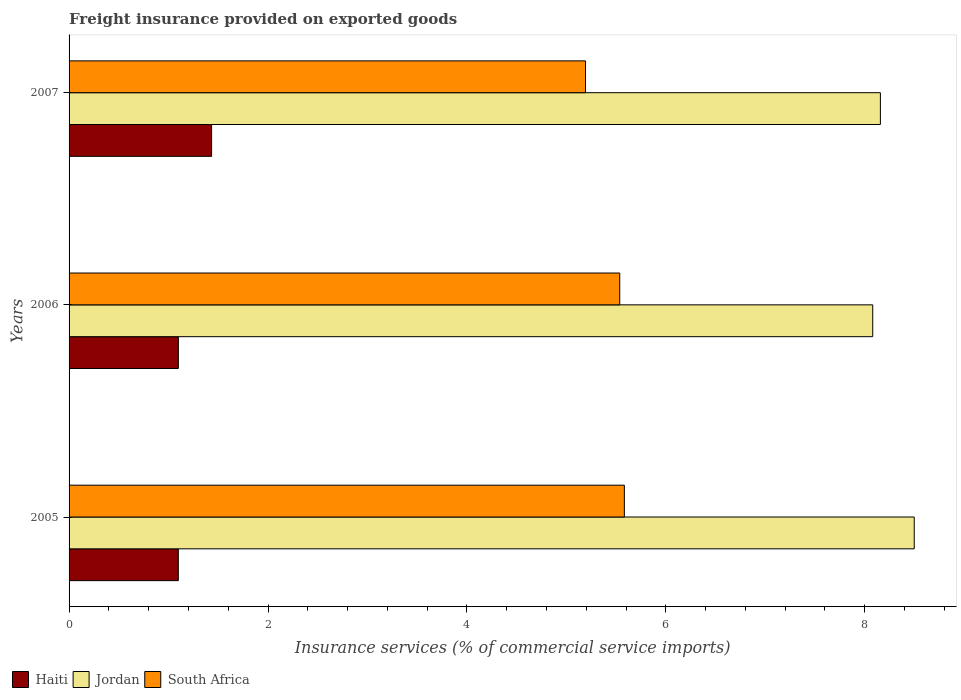How many groups of bars are there?
Offer a terse response. 3. Are the number of bars on each tick of the Y-axis equal?
Ensure brevity in your answer.  Yes. How many bars are there on the 2nd tick from the top?
Ensure brevity in your answer.  3. What is the freight insurance provided on exported goods in Haiti in 2005?
Give a very brief answer. 1.1. Across all years, what is the maximum freight insurance provided on exported goods in Jordan?
Give a very brief answer. 8.5. Across all years, what is the minimum freight insurance provided on exported goods in Jordan?
Your response must be concise. 8.08. In which year was the freight insurance provided on exported goods in South Africa maximum?
Offer a very short reply. 2005. In which year was the freight insurance provided on exported goods in South Africa minimum?
Offer a very short reply. 2007. What is the total freight insurance provided on exported goods in Haiti in the graph?
Your answer should be very brief. 3.63. What is the difference between the freight insurance provided on exported goods in Haiti in 2005 and that in 2006?
Offer a terse response. -0. What is the difference between the freight insurance provided on exported goods in South Africa in 2006 and the freight insurance provided on exported goods in Jordan in 2005?
Offer a very short reply. -2.96. What is the average freight insurance provided on exported goods in Jordan per year?
Offer a very short reply. 8.24. In the year 2006, what is the difference between the freight insurance provided on exported goods in Haiti and freight insurance provided on exported goods in South Africa?
Offer a terse response. -4.44. What is the ratio of the freight insurance provided on exported goods in Haiti in 2005 to that in 2007?
Ensure brevity in your answer.  0.77. Is the difference between the freight insurance provided on exported goods in Haiti in 2005 and 2006 greater than the difference between the freight insurance provided on exported goods in South Africa in 2005 and 2006?
Provide a short and direct response. No. What is the difference between the highest and the second highest freight insurance provided on exported goods in Jordan?
Provide a succinct answer. 0.34. What is the difference between the highest and the lowest freight insurance provided on exported goods in Jordan?
Your answer should be compact. 0.42. In how many years, is the freight insurance provided on exported goods in Haiti greater than the average freight insurance provided on exported goods in Haiti taken over all years?
Keep it short and to the point. 1. Is the sum of the freight insurance provided on exported goods in Jordan in 2005 and 2006 greater than the maximum freight insurance provided on exported goods in South Africa across all years?
Make the answer very short. Yes. What does the 2nd bar from the top in 2007 represents?
Make the answer very short. Jordan. What does the 2nd bar from the bottom in 2006 represents?
Your response must be concise. Jordan. How many years are there in the graph?
Provide a succinct answer. 3. Are the values on the major ticks of X-axis written in scientific E-notation?
Offer a very short reply. No. Does the graph contain any zero values?
Offer a terse response. No. Where does the legend appear in the graph?
Provide a short and direct response. Bottom left. How many legend labels are there?
Provide a short and direct response. 3. What is the title of the graph?
Make the answer very short. Freight insurance provided on exported goods. Does "Guam" appear as one of the legend labels in the graph?
Offer a terse response. No. What is the label or title of the X-axis?
Ensure brevity in your answer.  Insurance services (% of commercial service imports). What is the label or title of the Y-axis?
Your response must be concise. Years. What is the Insurance services (% of commercial service imports) of Haiti in 2005?
Keep it short and to the point. 1.1. What is the Insurance services (% of commercial service imports) of Jordan in 2005?
Your answer should be compact. 8.5. What is the Insurance services (% of commercial service imports) of South Africa in 2005?
Offer a terse response. 5.58. What is the Insurance services (% of commercial service imports) of Haiti in 2006?
Provide a short and direct response. 1.1. What is the Insurance services (% of commercial service imports) in Jordan in 2006?
Provide a short and direct response. 8.08. What is the Insurance services (% of commercial service imports) of South Africa in 2006?
Give a very brief answer. 5.54. What is the Insurance services (% of commercial service imports) of Haiti in 2007?
Your answer should be compact. 1.43. What is the Insurance services (% of commercial service imports) in Jordan in 2007?
Make the answer very short. 8.16. What is the Insurance services (% of commercial service imports) in South Africa in 2007?
Your answer should be compact. 5.19. Across all years, what is the maximum Insurance services (% of commercial service imports) in Haiti?
Offer a very short reply. 1.43. Across all years, what is the maximum Insurance services (% of commercial service imports) of Jordan?
Ensure brevity in your answer.  8.5. Across all years, what is the maximum Insurance services (% of commercial service imports) in South Africa?
Offer a very short reply. 5.58. Across all years, what is the minimum Insurance services (% of commercial service imports) in Haiti?
Your answer should be compact. 1.1. Across all years, what is the minimum Insurance services (% of commercial service imports) of Jordan?
Make the answer very short. 8.08. Across all years, what is the minimum Insurance services (% of commercial service imports) in South Africa?
Ensure brevity in your answer.  5.19. What is the total Insurance services (% of commercial service imports) of Haiti in the graph?
Keep it short and to the point. 3.63. What is the total Insurance services (% of commercial service imports) in Jordan in the graph?
Offer a very short reply. 24.73. What is the total Insurance services (% of commercial service imports) in South Africa in the graph?
Your response must be concise. 16.31. What is the difference between the Insurance services (% of commercial service imports) in Haiti in 2005 and that in 2006?
Ensure brevity in your answer.  -0. What is the difference between the Insurance services (% of commercial service imports) in Jordan in 2005 and that in 2006?
Make the answer very short. 0.42. What is the difference between the Insurance services (% of commercial service imports) in South Africa in 2005 and that in 2006?
Offer a very short reply. 0.05. What is the difference between the Insurance services (% of commercial service imports) of Haiti in 2005 and that in 2007?
Ensure brevity in your answer.  -0.33. What is the difference between the Insurance services (% of commercial service imports) of Jordan in 2005 and that in 2007?
Make the answer very short. 0.34. What is the difference between the Insurance services (% of commercial service imports) of South Africa in 2005 and that in 2007?
Ensure brevity in your answer.  0.39. What is the difference between the Insurance services (% of commercial service imports) of Haiti in 2006 and that in 2007?
Your response must be concise. -0.33. What is the difference between the Insurance services (% of commercial service imports) of Jordan in 2006 and that in 2007?
Give a very brief answer. -0.08. What is the difference between the Insurance services (% of commercial service imports) in South Africa in 2006 and that in 2007?
Ensure brevity in your answer.  0.34. What is the difference between the Insurance services (% of commercial service imports) in Haiti in 2005 and the Insurance services (% of commercial service imports) in Jordan in 2006?
Make the answer very short. -6.98. What is the difference between the Insurance services (% of commercial service imports) of Haiti in 2005 and the Insurance services (% of commercial service imports) of South Africa in 2006?
Make the answer very short. -4.44. What is the difference between the Insurance services (% of commercial service imports) in Jordan in 2005 and the Insurance services (% of commercial service imports) in South Africa in 2006?
Your response must be concise. 2.96. What is the difference between the Insurance services (% of commercial service imports) of Haiti in 2005 and the Insurance services (% of commercial service imports) of Jordan in 2007?
Your answer should be compact. -7.06. What is the difference between the Insurance services (% of commercial service imports) of Haiti in 2005 and the Insurance services (% of commercial service imports) of South Africa in 2007?
Keep it short and to the point. -4.09. What is the difference between the Insurance services (% of commercial service imports) in Jordan in 2005 and the Insurance services (% of commercial service imports) in South Africa in 2007?
Provide a short and direct response. 3.31. What is the difference between the Insurance services (% of commercial service imports) of Haiti in 2006 and the Insurance services (% of commercial service imports) of Jordan in 2007?
Give a very brief answer. -7.06. What is the difference between the Insurance services (% of commercial service imports) in Haiti in 2006 and the Insurance services (% of commercial service imports) in South Africa in 2007?
Make the answer very short. -4.09. What is the difference between the Insurance services (% of commercial service imports) in Jordan in 2006 and the Insurance services (% of commercial service imports) in South Africa in 2007?
Your response must be concise. 2.89. What is the average Insurance services (% of commercial service imports) of Haiti per year?
Make the answer very short. 1.21. What is the average Insurance services (% of commercial service imports) in Jordan per year?
Offer a very short reply. 8.24. What is the average Insurance services (% of commercial service imports) of South Africa per year?
Provide a succinct answer. 5.44. In the year 2005, what is the difference between the Insurance services (% of commercial service imports) of Haiti and Insurance services (% of commercial service imports) of Jordan?
Your response must be concise. -7.4. In the year 2005, what is the difference between the Insurance services (% of commercial service imports) in Haiti and Insurance services (% of commercial service imports) in South Africa?
Keep it short and to the point. -4.48. In the year 2005, what is the difference between the Insurance services (% of commercial service imports) of Jordan and Insurance services (% of commercial service imports) of South Africa?
Your answer should be very brief. 2.91. In the year 2006, what is the difference between the Insurance services (% of commercial service imports) of Haiti and Insurance services (% of commercial service imports) of Jordan?
Ensure brevity in your answer.  -6.98. In the year 2006, what is the difference between the Insurance services (% of commercial service imports) of Haiti and Insurance services (% of commercial service imports) of South Africa?
Give a very brief answer. -4.44. In the year 2006, what is the difference between the Insurance services (% of commercial service imports) of Jordan and Insurance services (% of commercial service imports) of South Africa?
Your answer should be very brief. 2.54. In the year 2007, what is the difference between the Insurance services (% of commercial service imports) of Haiti and Insurance services (% of commercial service imports) of Jordan?
Your answer should be very brief. -6.72. In the year 2007, what is the difference between the Insurance services (% of commercial service imports) in Haiti and Insurance services (% of commercial service imports) in South Africa?
Keep it short and to the point. -3.76. In the year 2007, what is the difference between the Insurance services (% of commercial service imports) in Jordan and Insurance services (% of commercial service imports) in South Africa?
Your answer should be compact. 2.96. What is the ratio of the Insurance services (% of commercial service imports) in Jordan in 2005 to that in 2006?
Ensure brevity in your answer.  1.05. What is the ratio of the Insurance services (% of commercial service imports) of South Africa in 2005 to that in 2006?
Keep it short and to the point. 1.01. What is the ratio of the Insurance services (% of commercial service imports) in Haiti in 2005 to that in 2007?
Make the answer very short. 0.77. What is the ratio of the Insurance services (% of commercial service imports) in Jordan in 2005 to that in 2007?
Provide a short and direct response. 1.04. What is the ratio of the Insurance services (% of commercial service imports) of South Africa in 2005 to that in 2007?
Ensure brevity in your answer.  1.08. What is the ratio of the Insurance services (% of commercial service imports) in Haiti in 2006 to that in 2007?
Offer a terse response. 0.77. What is the ratio of the Insurance services (% of commercial service imports) of South Africa in 2006 to that in 2007?
Your answer should be very brief. 1.07. What is the difference between the highest and the second highest Insurance services (% of commercial service imports) in Haiti?
Provide a short and direct response. 0.33. What is the difference between the highest and the second highest Insurance services (% of commercial service imports) in Jordan?
Provide a short and direct response. 0.34. What is the difference between the highest and the second highest Insurance services (% of commercial service imports) in South Africa?
Your answer should be compact. 0.05. What is the difference between the highest and the lowest Insurance services (% of commercial service imports) of Haiti?
Ensure brevity in your answer.  0.33. What is the difference between the highest and the lowest Insurance services (% of commercial service imports) in Jordan?
Ensure brevity in your answer.  0.42. What is the difference between the highest and the lowest Insurance services (% of commercial service imports) of South Africa?
Your response must be concise. 0.39. 